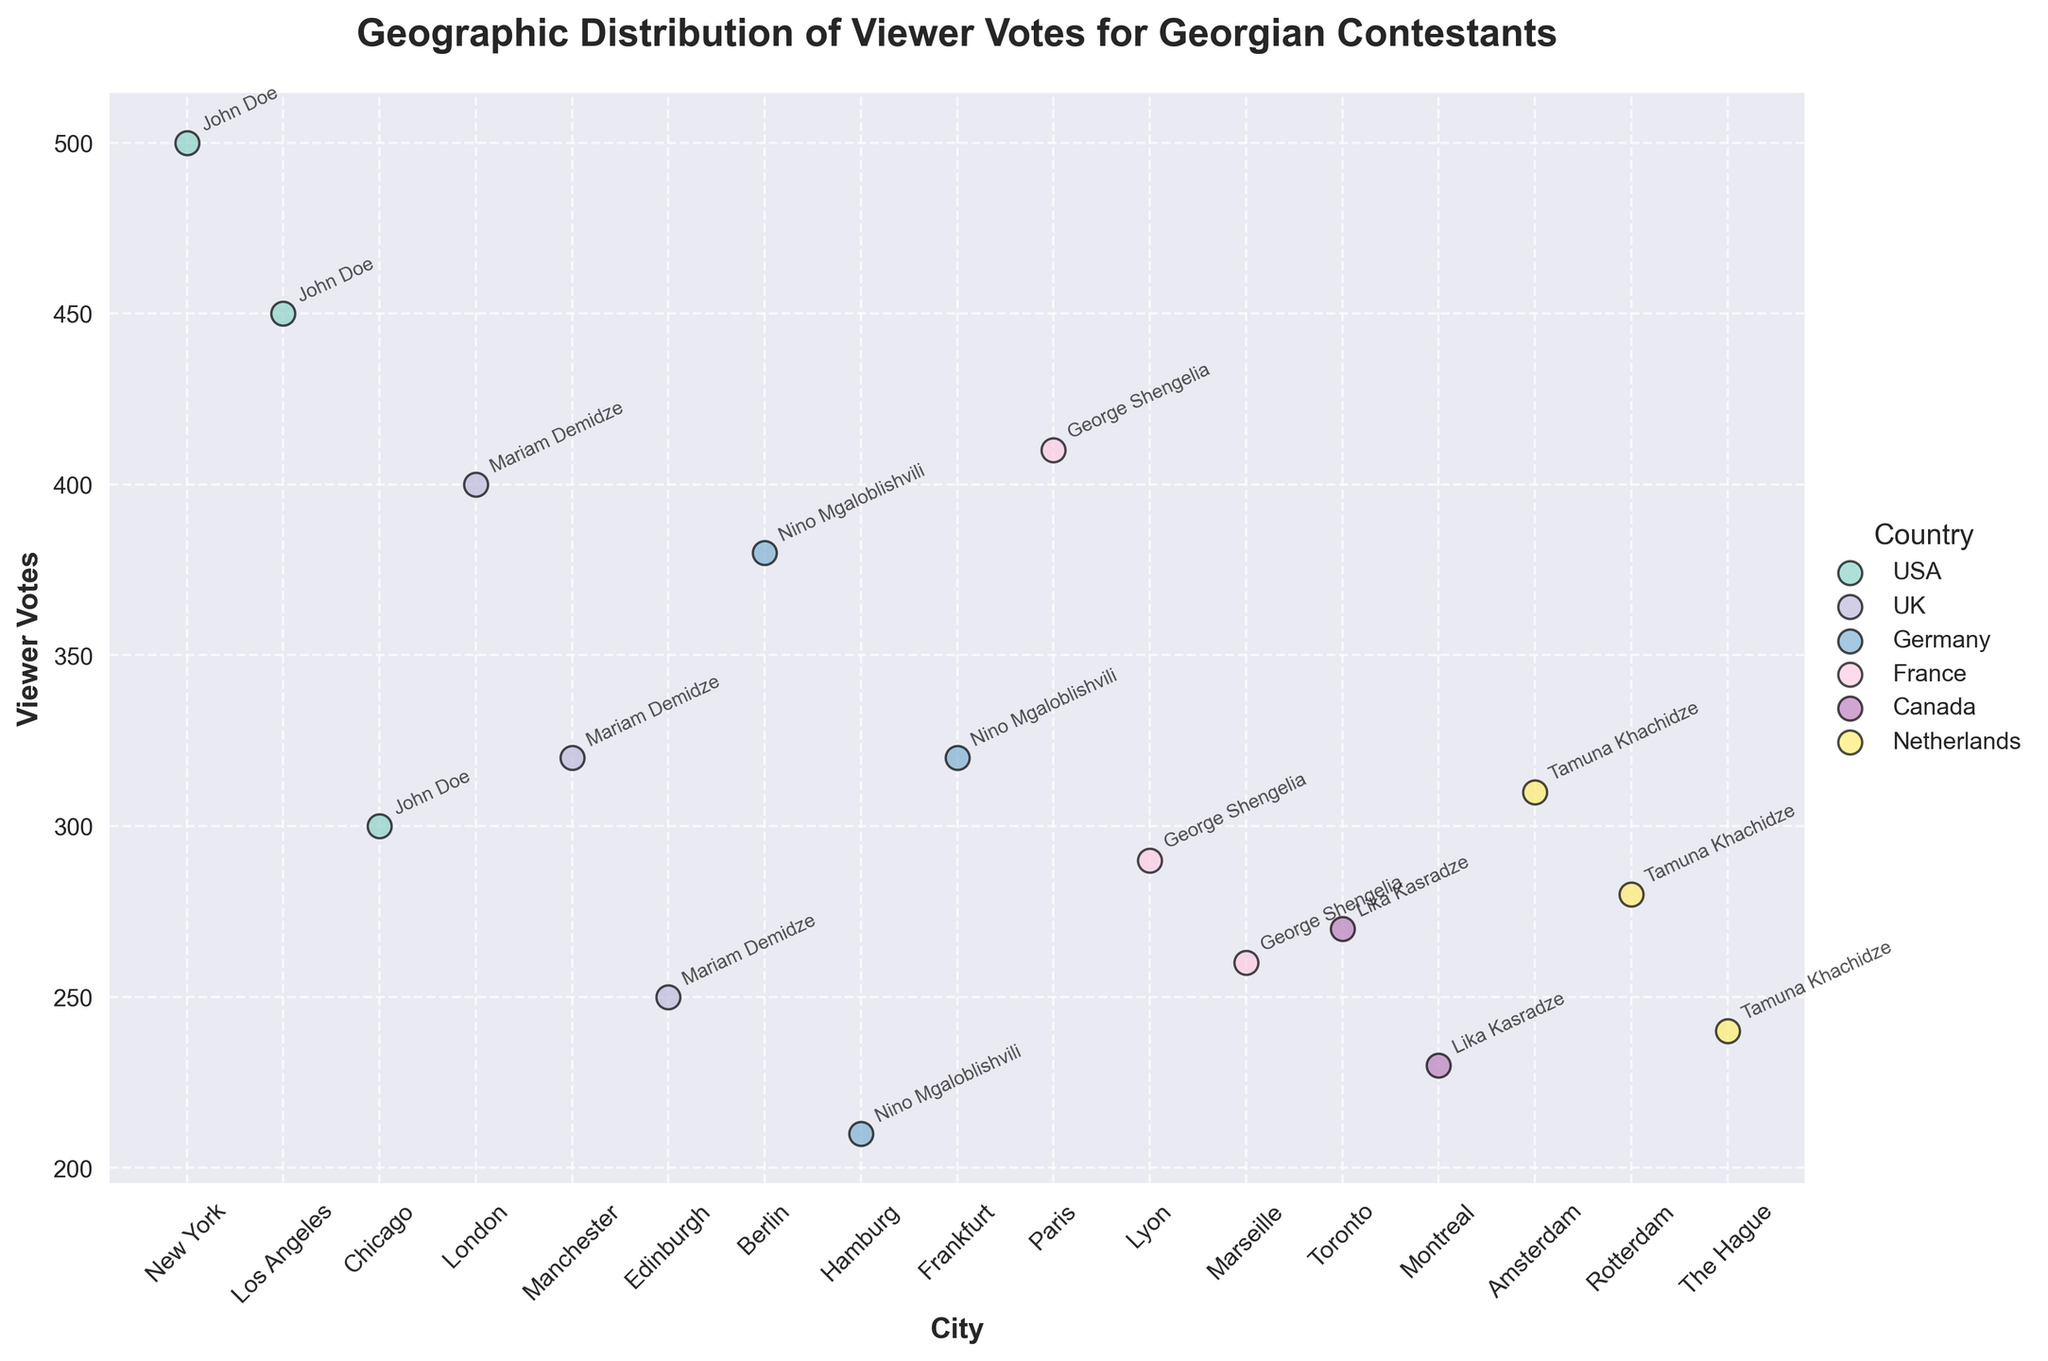What is the title of the plot? The title can be seen at the top center of the plot in bold and larger font size. It reads "Geographic Distribution of Viewer Votes for Georgian Contestants".
Answer: Geographic Distribution of Viewer Votes for Georgian Contestants Which city in the USA has the highest viewer votes for John Doe? By looking at the scatter plot and focusing on the points labeled as "John Doe" within the USA, we see that New York has the highest value as the point is at 500 votes.
Answer: New York How many countries are represented in the plot? The legend on the right side of the plot lists all countries represented by different colors. Counting these, we see USA, UK, Germany, France, Canada, and Netherlands.
Answer: Six What city has the lowest viewer votes for George Shengelia? By referring to the cities plotted for George Shengelia, we find that Marseille has the lowest point at 260 votes on the y-axis.
Answer: Marseille Which contestant received the highest number of viewer votes? Looking across all contestant labels and viewer vote values, the highest point on the y-axis is for John Doe in New York with 500 votes.
Answer: John Doe What is the average number of viewer votes for Mariam Demidze? Sum the viewer votes for Mariam Demidze and divide by the number of cities: (400 + 320 + 250)/3 = 970/3.
Answer: 323.33 Which contestant has data points in Canada? By locating the data points within Canada from the figure and noting the contestant labels, only Lika Kasradze appears in Toronto and Montreal.
Answer: Lika Kasradze How does viewer votes compare between Tamuna Khachidze in Amsterdam and Rotterdam? Looking at the y-axis values for Tamuna Khachidze in Amsterdam and Rotterdam, we see votes in Amsterdam are 310 and in Rotterdam are 280, so Amsterdam has more votes.
Answer: Amsterdam has more votes What is the difference in viewer votes between the city with the highest and the lowest votes for John Doe? For John Doe, New York has 500 votes (highest) and Chicago has 300 votes (lowest). The difference is 500 - 300.
Answer: 200 Is there a general trend in viewer votes across cities for Nino Mgaloblishvili in Germany? Observing the points for Nino Mgaloblishvili in Berlin, Hamburg, and Frankfurt, we notice there's no upward or downward trend. The votes are 380, 210, and 320 respectively, fluctuating without a clear pattern.
Answer: No clear trend 